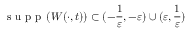Convert formula to latex. <formula><loc_0><loc_0><loc_500><loc_500>s u p p \left ( W ( \cdot , t ) \right ) \subset ( - \frac { 1 } { \varepsilon } , - \varepsilon ) \cup ( \varepsilon , \frac { 1 } { \varepsilon } )</formula> 